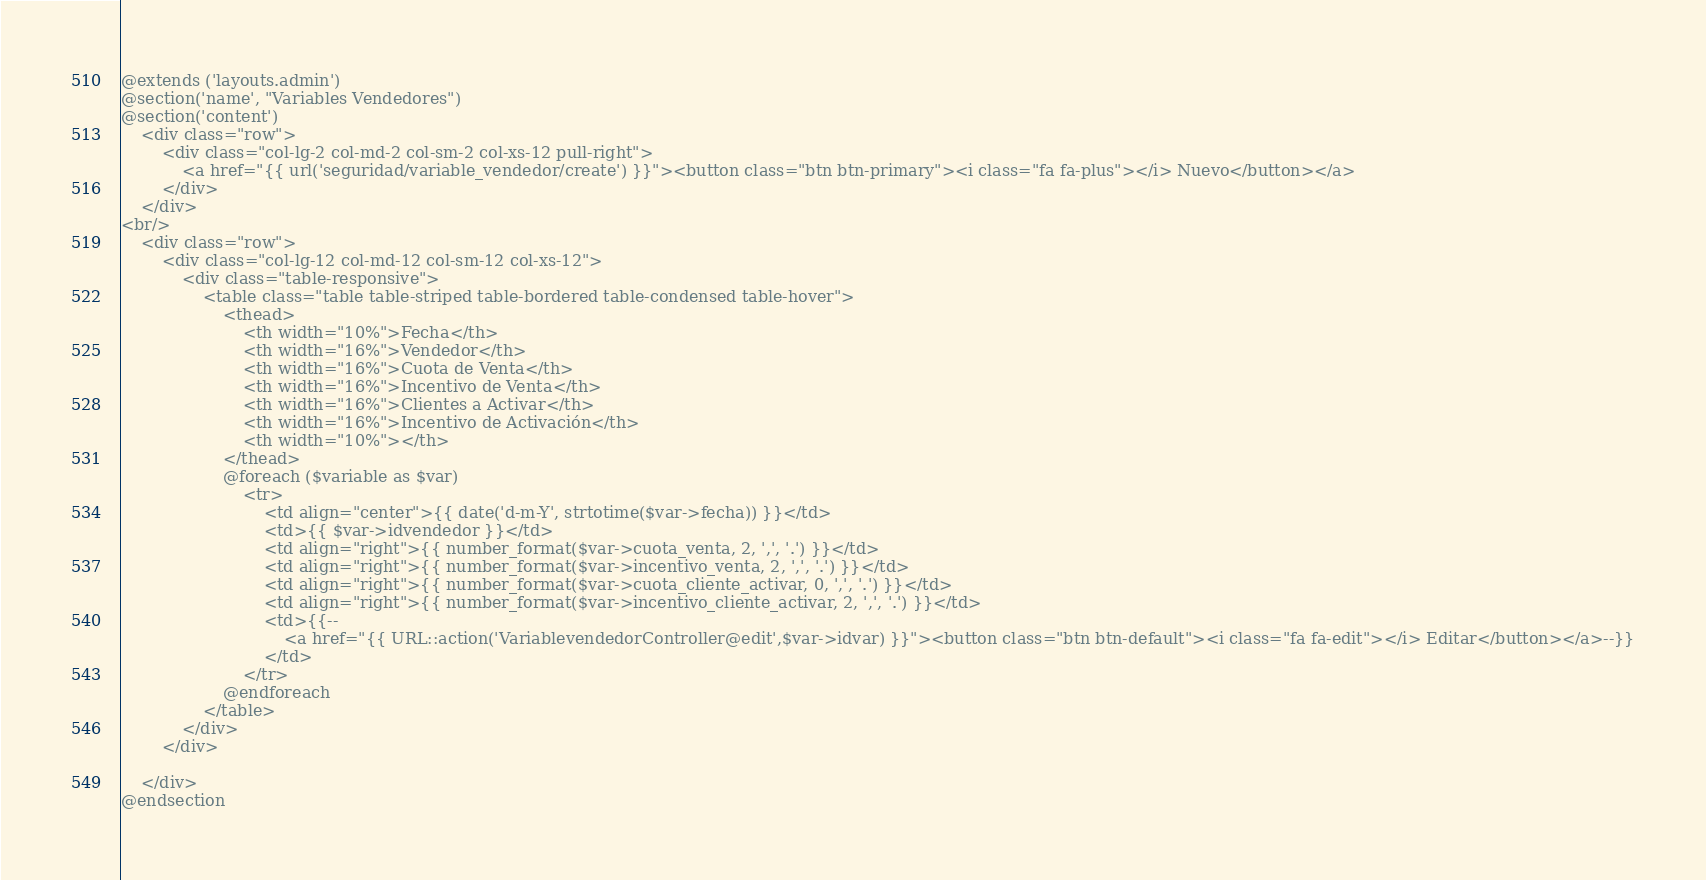Convert code to text. <code><loc_0><loc_0><loc_500><loc_500><_PHP_>@extends ('layouts.admin')
@section('name', "Variables Vendedores")
@section('content')
	<div class="row">
		<div class="col-lg-2 col-md-2 col-sm-2 col-xs-12 pull-right">
			<a href="{{ url('seguridad/variable_vendedor/create') }}"><button class="btn btn-primary"><i class="fa fa-plus"></i> Nuevo</button></a>
		</div>
	</div>
<br/>
	<div class="row">
		<div class="col-lg-12 col-md-12 col-sm-12 col-xs-12">
			<div class="table-responsive">
				<table class="table table-striped table-bordered table-condensed table-hover">
					<thead>
						<th width="10%">Fecha</th>
						<th width="16%">Vendedor</th>
						<th width="16%">Cuota de Venta</th>
						<th width="16%">Incentivo de Venta</th>
						<th width="16%">Clientes a Activar</th>
						<th width="16%">Incentivo de Activación</th>
						<th width="10%"></th>
					</thead>
					@foreach ($variable as $var)
						<tr>
							<td align="center">{{ date('d-m-Y', strtotime($var->fecha)) }}</td>
							<td>{{ $var->idvendedor }}</td>
							<td align="right">{{ number_format($var->cuota_venta, 2, ',', '.') }}</td>
							<td align="right">{{ number_format($var->incentivo_venta, 2, ',', '.') }}</td>
							<td align="right">{{ number_format($var->cuota_cliente_activar, 0, ',', '.') }}</td>
							<td align="right">{{ number_format($var->incentivo_cliente_activar, 2, ',', '.') }}</td>
							<td>{{--
								<a href="{{ URL::action('VariablevendedorController@edit',$var->idvar) }}"><button class="btn btn-default"><i class="fa fa-edit"></i> Editar</button></a>--}}
							</td>
						</tr>
					@endforeach
				</table>
			</div>
		</div>

	</div>
@endsection</code> 